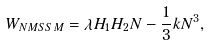Convert formula to latex. <formula><loc_0><loc_0><loc_500><loc_500>W _ { N M S S M } = \lambda H _ { 1 } H _ { 2 } N - \frac { 1 } { 3 } k N ^ { 3 } ,</formula> 